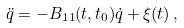<formula> <loc_0><loc_0><loc_500><loc_500>\ddot { q } = - B _ { 1 1 } ( t , t _ { 0 } ) \dot { q } + \xi ( t ) \, ,</formula> 